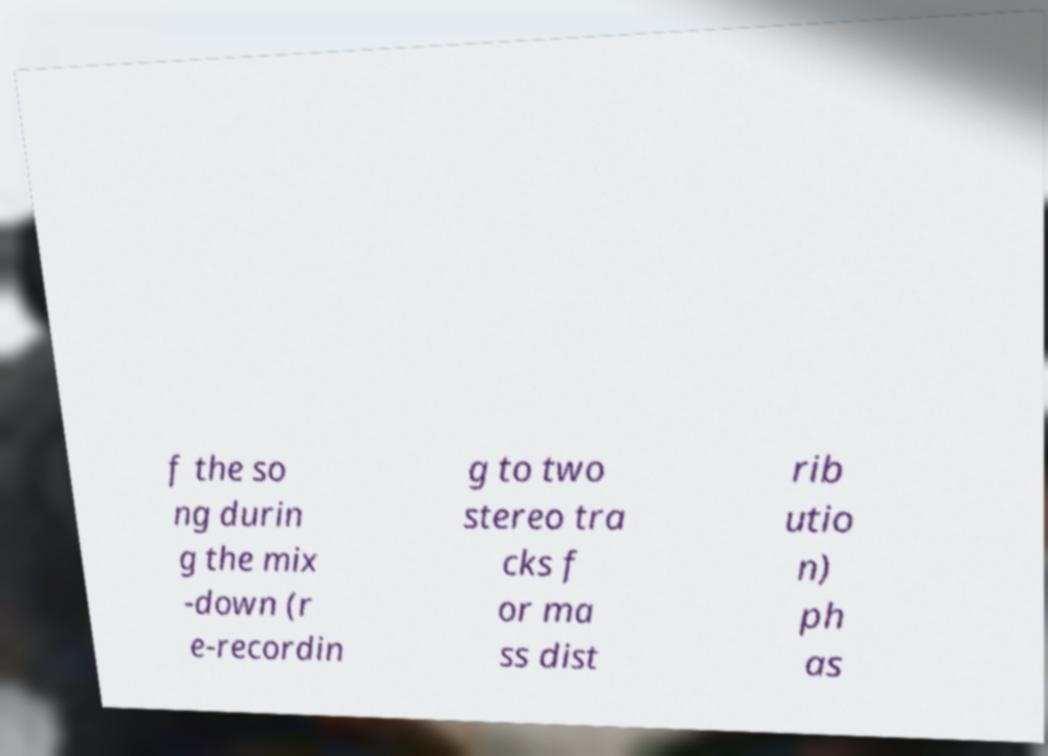What messages or text are displayed in this image? I need them in a readable, typed format. f the so ng durin g the mix -down (r e-recordin g to two stereo tra cks f or ma ss dist rib utio n) ph as 